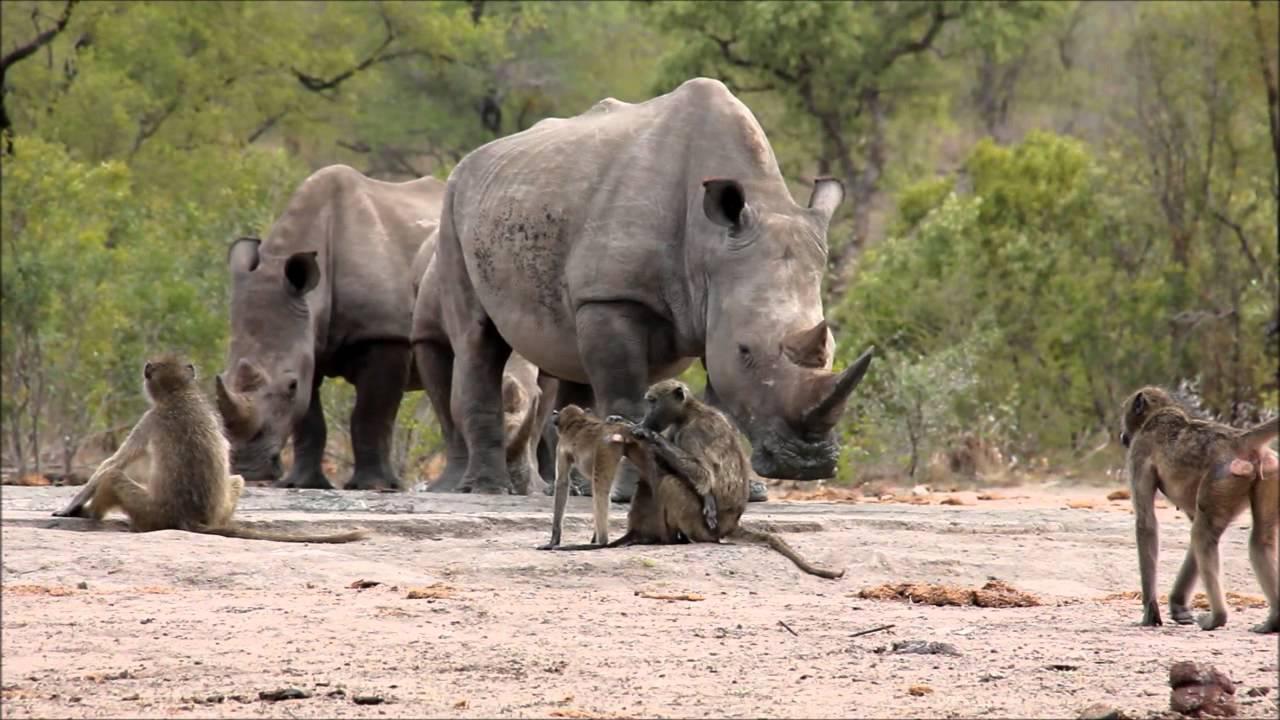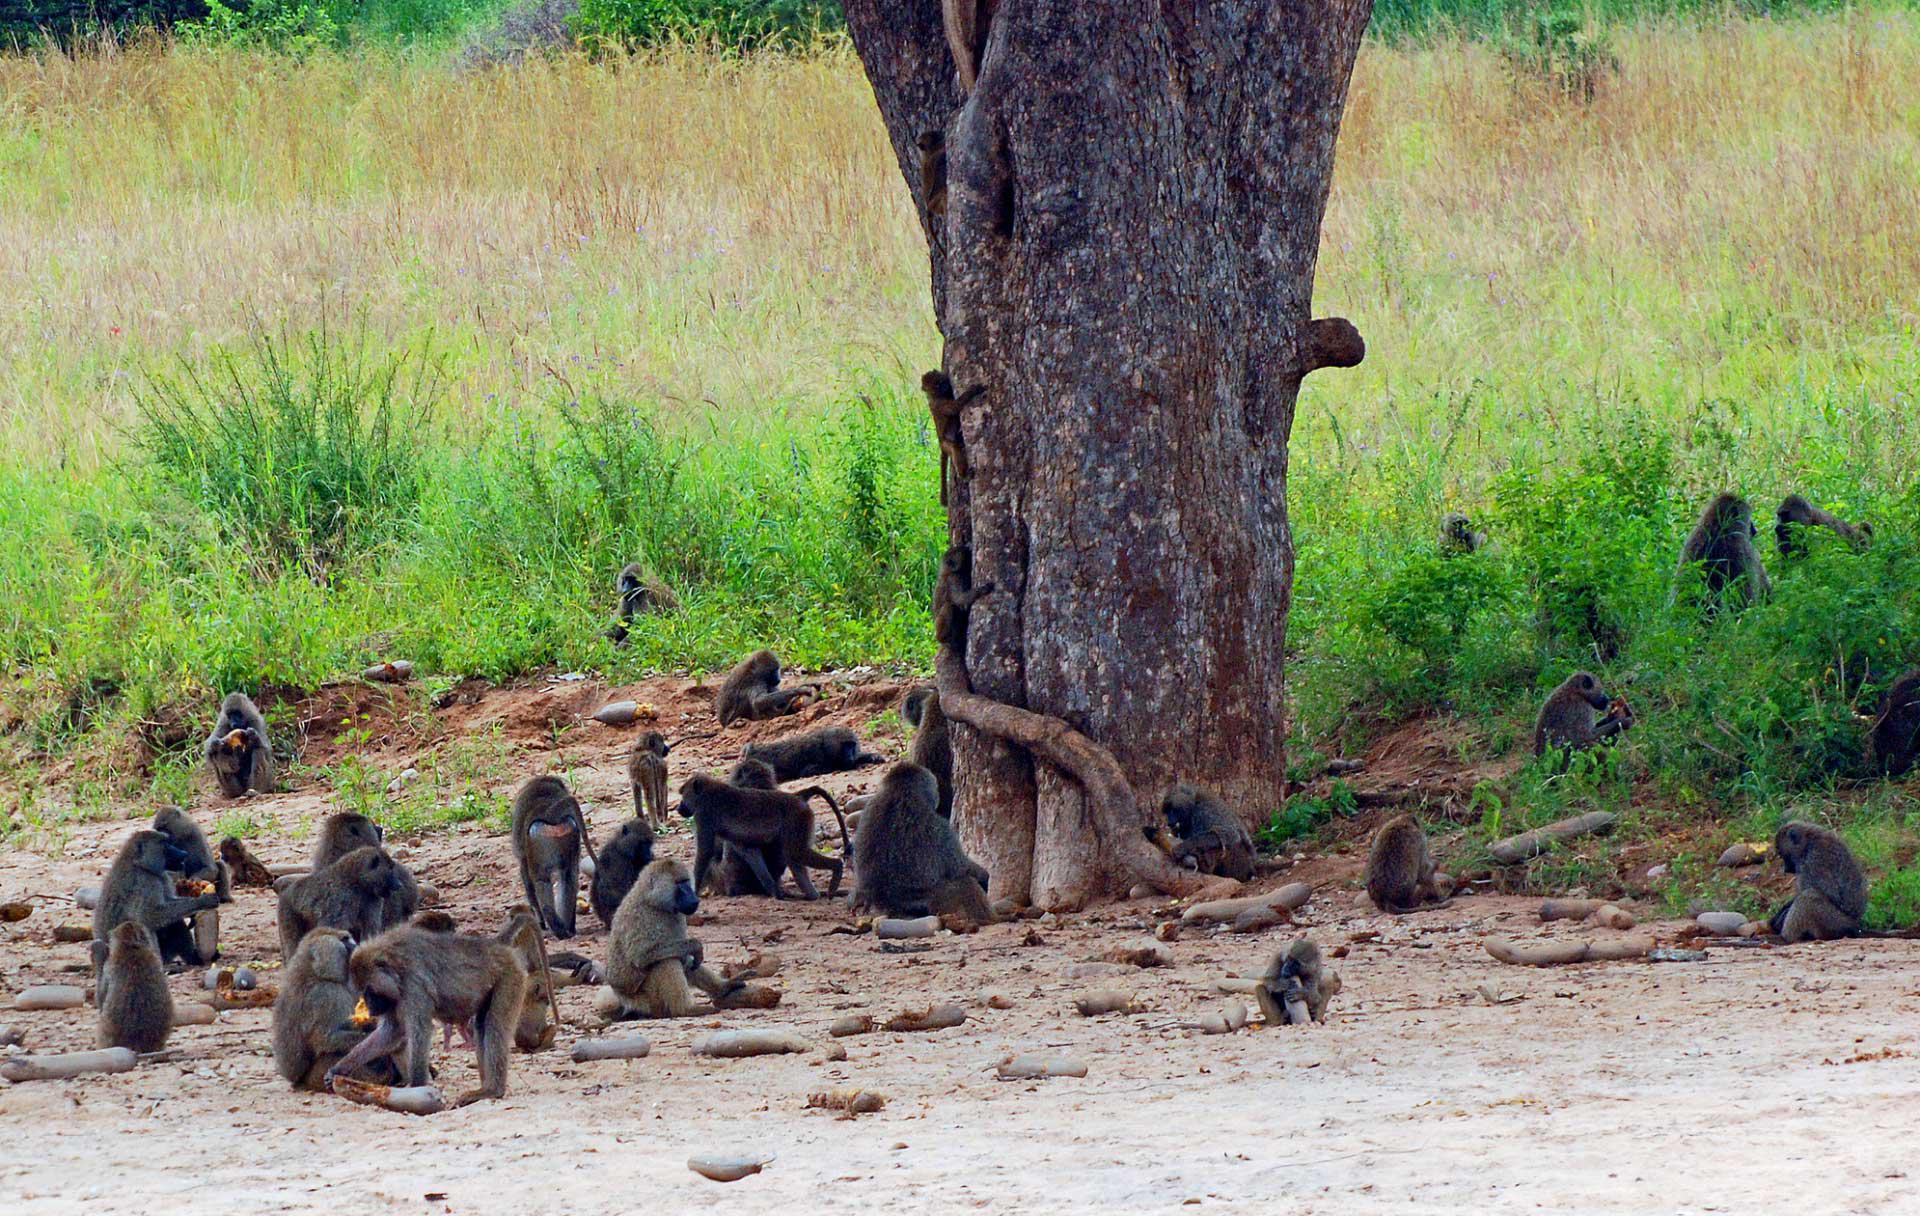The first image is the image on the left, the second image is the image on the right. Considering the images on both sides, is "There are no more than four monkeys in the image on the left." valid? Answer yes or no. Yes. 